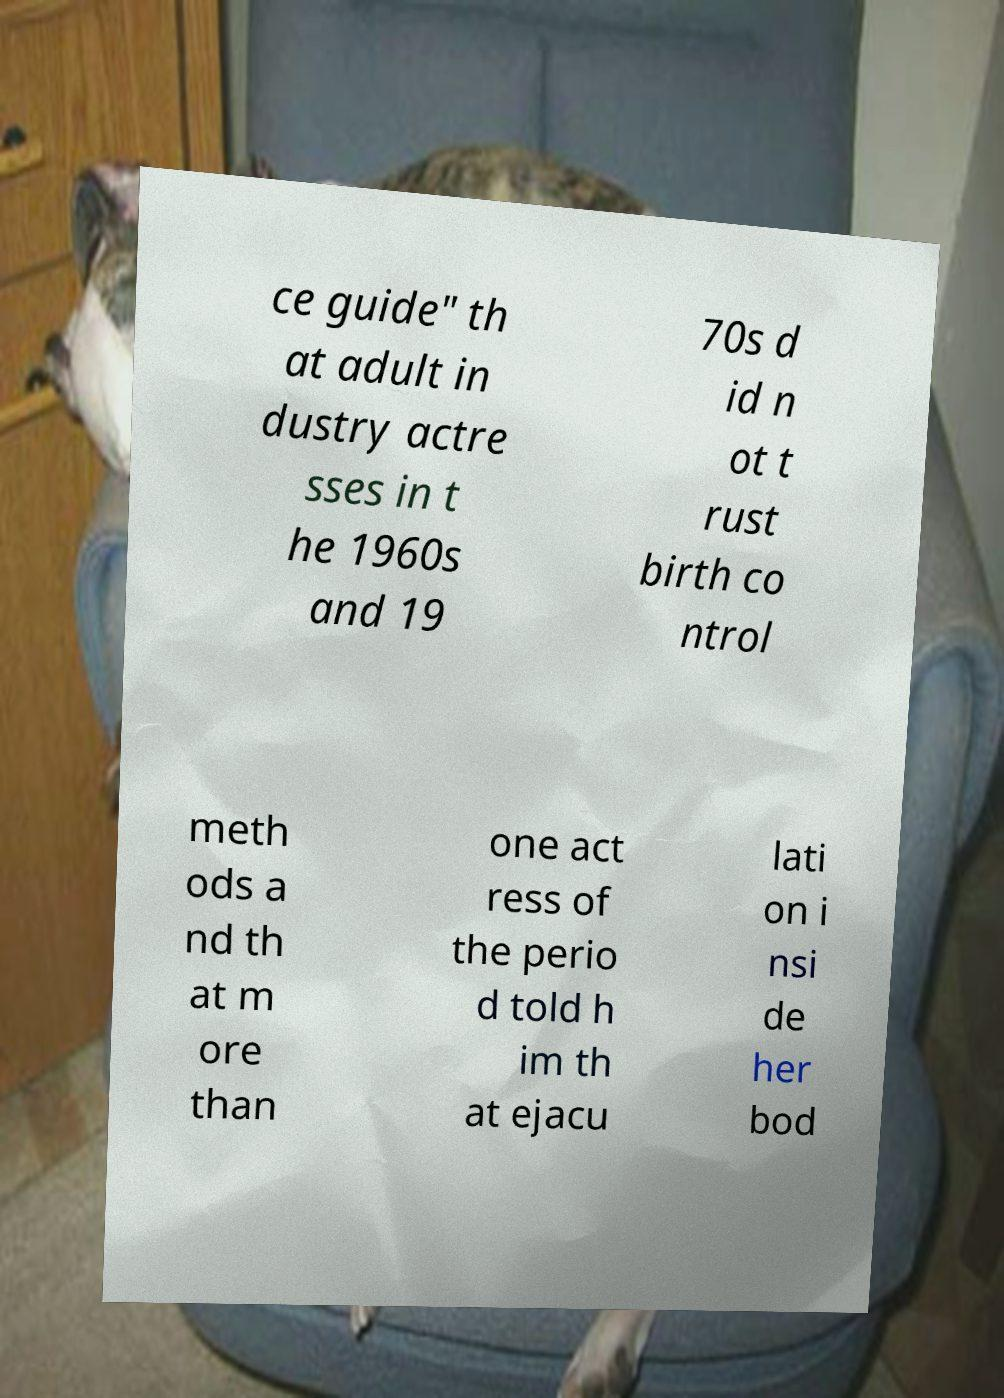Please read and relay the text visible in this image. What does it say? ce guide" th at adult in dustry actre sses in t he 1960s and 19 70s d id n ot t rust birth co ntrol meth ods a nd th at m ore than one act ress of the perio d told h im th at ejacu lati on i nsi de her bod 